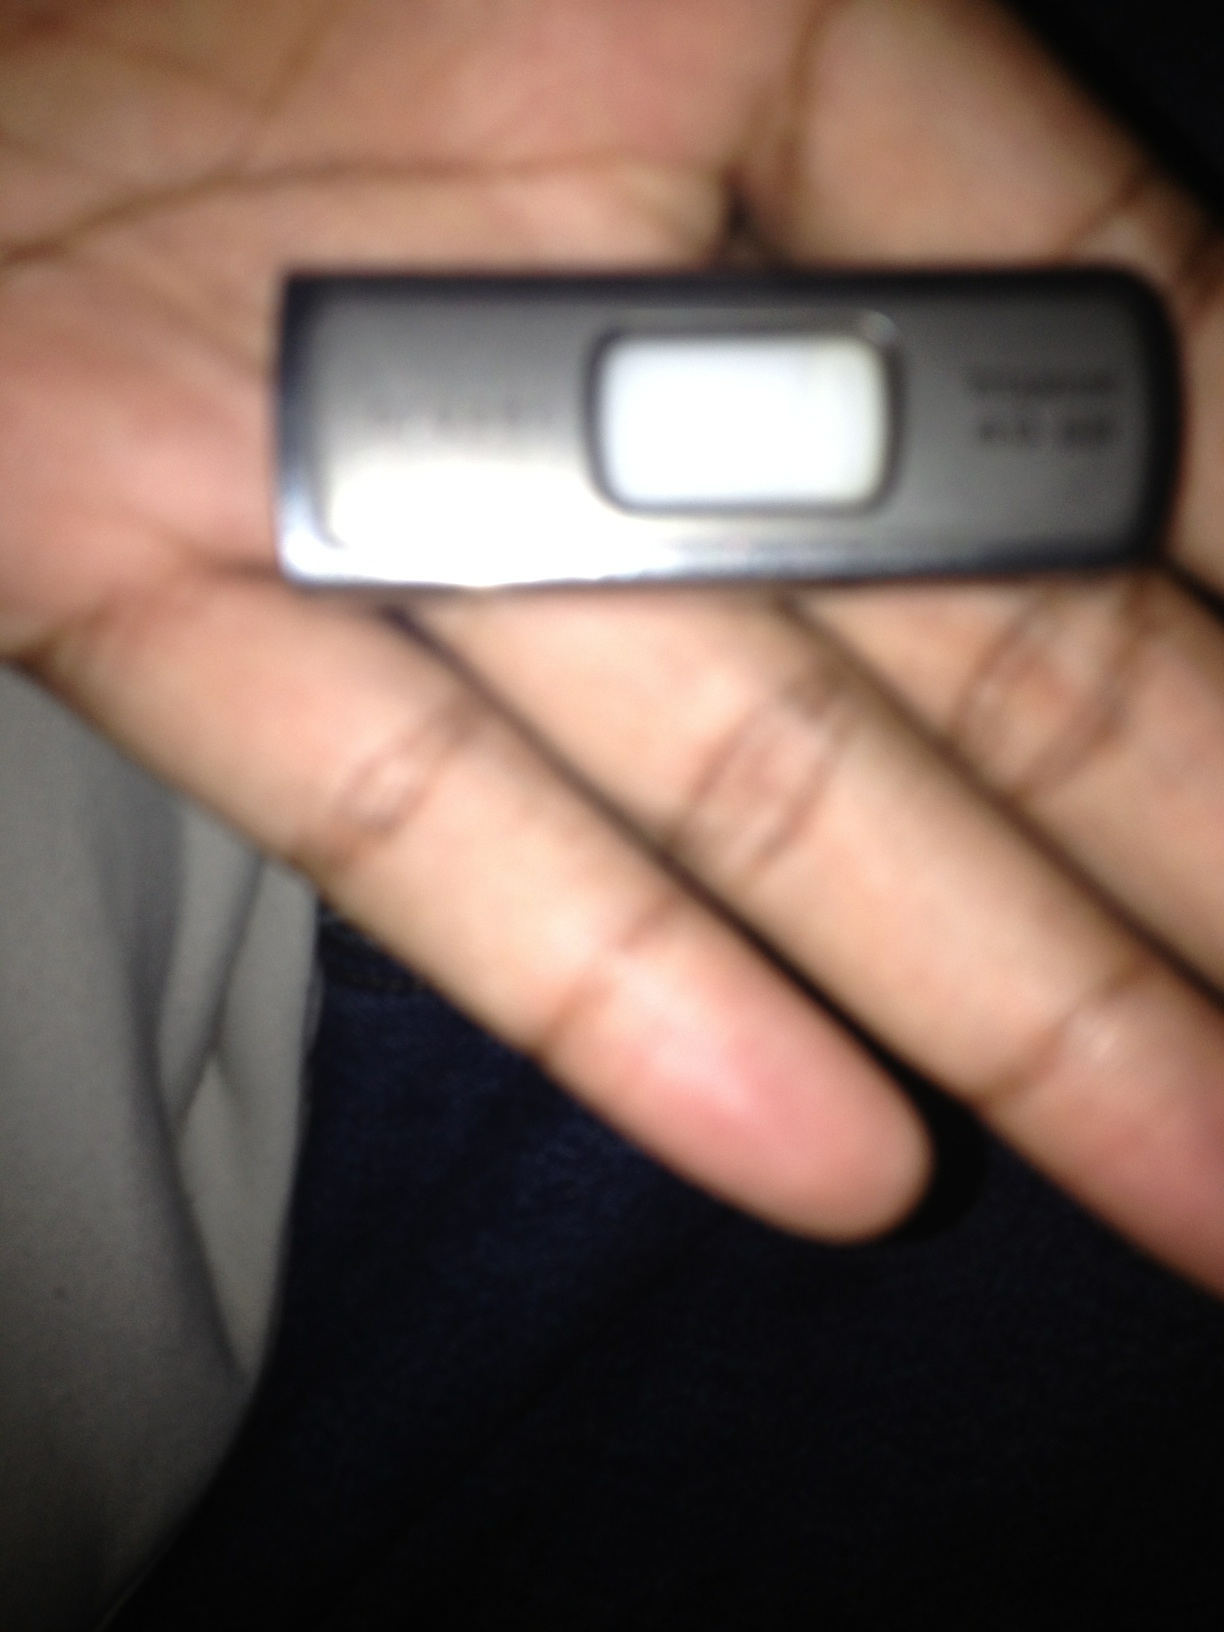What type of data can be stored on this device? A USB flash drive can store various types of data, including documents, images, videos, music files, software programs, backup files, and more. It's versatile and easy to use for transferring files between different computers, making it a handy tool for both personal and professional use. 